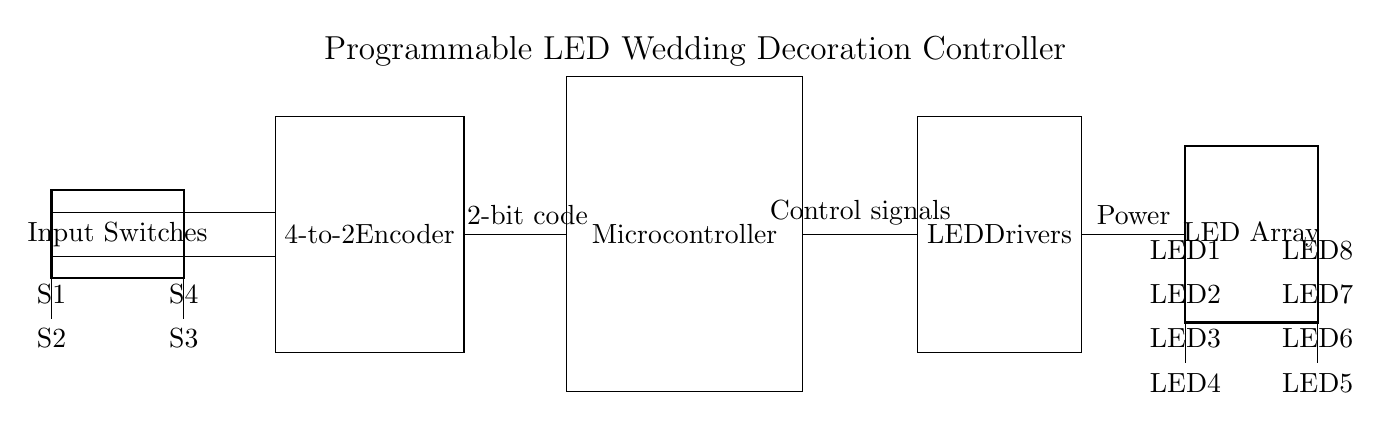What type of components are used in this circuit? The circuit contains input switches, a 4-to-2 encoder, a microcontroller, LED drivers, and an LED array. These components are essential for controlling the programmable LED decoration.
Answer: input switches, 4-to-2 encoder, microcontroller, LED drivers, LED array How many input switches are there in total? The diagram shows four input switches labeled S1, S2, S3, and S4. Counting these, we can confirm that there are a total of four input switches connected to the encoder.
Answer: four What does the encoder do in this circuit? The 4-to-2 encoder converts the input signals from the four switches into a 2-bit binary code, which is then sent to the microcontroller for further processing.
Answer: converts signals to binary code What is the role of the microcontroller? The microcontroller receives the 2-bit code from the encoder and issues control signals to the LED drivers based on that input. It acts as the brain of the circuit, processing input and controlling output.
Answer: issues control signals How many LEDs are supported in this circuit? The LED array consists of eight individual LEDs, as indicated by the eight pins labeled LED1 through LED8. This means the circuit can control up to eight different LED lights.
Answer: eight What is the relationship between the switches and the LED array? The input switches determine which LEDs are activated. The states of the switches are encoded into binary and processed by the microcontroller to control the specific LEDs in the array.
Answer: switches control LEDs Which component provides power to the LED array? The LED drivers supply power to the LED array, as shown by the connection from the drivers to the LEDs, indicating they manage the power required for LED operation.
Answer: LED drivers 